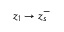Convert formula to latex. <formula><loc_0><loc_0><loc_500><loc_500>z _ { 1 } \rightarrow z _ { s } ^ { - }</formula> 